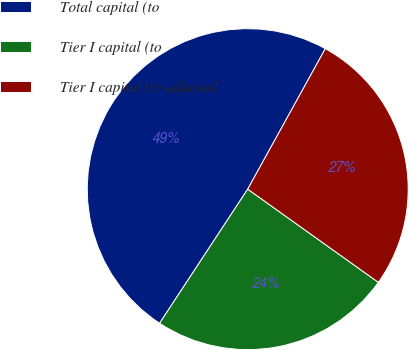Convert chart to OTSL. <chart><loc_0><loc_0><loc_500><loc_500><pie_chart><fcel>Total capital (to<fcel>Tier I capital (to<fcel>Tier I capital (to adjusted<nl><fcel>48.78%<fcel>24.39%<fcel>26.83%<nl></chart> 